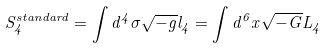Convert formula to latex. <formula><loc_0><loc_0><loc_500><loc_500>S ^ { s t a n d a r d } _ { 4 } = \int d ^ { 4 } \sigma \sqrt { - g } l _ { 4 } = \int d ^ { 6 } x \sqrt { - G } L _ { 4 }</formula> 